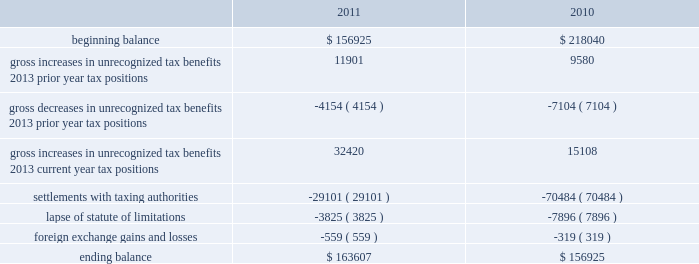A valuation allowance has been established for certain deferred tax assets related to the impairment of investments .
Accounting for uncertainty in income taxes during fiscal 2011 and 2010 , our aggregate changes in our total gross amount of unrecognized tax benefits are summarized as follows ( in thousands ) : beginning balance gross increases in unrecognized tax benefits 2013 prior year tax positions gross decreases in unrecognized tax benefits 2013 prior year tax positions gross increases in unrecognized tax benefits 2013 current year tax positions settlements with taxing authorities lapse of statute of limitations foreign exchange gains and losses ending balance $ 156925 11901 ( 4154 ) 32420 ( 29101 ) ( 3825 ) $ 163607 $ 218040 ( 7104 ) 15108 ( 70484 ) ( 7896 ) $ 156925 as of december 2 , 2011 , the combined amount of accrued interest and penalties related to tax positions taken on our tax returns and included in non-current income taxes payable was approximately $ 12.3 million .
We file income tax returns in the u.s .
On a federal basis and in many u.s .
State and foreign jurisdictions .
We are subject to the continual examination of our income tax returns by the irs and other domestic and foreign tax authorities .
Our major tax jurisdictions are the u.s. , ireland and california .
For california , ireland and the u.s. , the earliest fiscal years open for examination are 2005 , 2006 and 2008 , respectively .
We regularly assess the likelihood of outcomes resulting from these examinations to determine the adequacy of our provision for income taxes and have reserved for potential adjustments that may result from the current examination .
We believe such estimates to be reasonable ; however , there can be no assurance that the final determination of any of these examinations will not have an adverse effect on our operating results and financial position .
In august 2011 , a canadian income tax examination covering our fiscal years 2005 through 2008 was completed .
Our accrued tax and interest related to these years was approximately $ 35 million and was previously reported in long-term income taxes payable .
We reclassified approximately $ 17 million to short-term income taxes payable and decreased deferred tax assets by approximately $ 18 million in conjunction with the aforementioned resolution .
The $ 17 million balance in short-term income taxes payable is partially secured by a letter of credit and is expected to be paid by the first quarter of fiscal 2012 .
In october 2010 , a u.s .
Income tax examination covering our fiscal years 2005 through 2007 was completed .
Our accrued tax and interest related to these years was $ 59 million and was previously reported in long-term income taxes payable .
We paid $ 20 million in conjunction with the aforementioned resolution .
A net income statement tax benefit in the fourth quarter of fiscal 2010 of $ 39 million resulted .
The timing of the resolution of income tax examinations is highly uncertain as are the amounts and timing of tax payments that are part of any audit settlement process .
These events could cause large fluctuations in the balance sheet classification of current and non-current assets and liabilities .
The company believes that before the end of fiscal 2012 , it is reasonably possible that either certain audits will conclude or statutes of limitations on certain income tax examination periods will expire , or both .
Given the uncertainties described above , we can only determine a range of estimated potential decreases in underlying unrecognized tax benefits ranging from $ 0 to approximately $ 40 million .
These amounts would decrease income tax expense under current gaap related to income taxes .
Note 11 .
Restructuring fiscal 2011 restructuring plan in the fourth quarter of fiscal 2011 , in order to better align our resources around our digital media and digital marketing strategies , we initiated a restructuring plan consisting of reductions of approximately 700 full-time positions worldwide and we recorded restructuring charges of approximately $ 78.6 million related to ongoing termination benefits for the position eliminated .
Table of contents adobe systems incorporated notes to consolidated financial statements ( continued ) .
A valuation allowance has been established for certain deferred tax assets related to the impairment of investments .
Accounting for uncertainty in income taxes during fiscal 2011 and 2010 , our aggregate changes in our total gross amount of unrecognized tax benefits are summarized as follows ( in thousands ) : beginning balance gross increases in unrecognized tax benefits 2013 prior year tax positions gross decreases in unrecognized tax benefits 2013 prior year tax positions gross increases in unrecognized tax benefits 2013 current year tax positions settlements with taxing authorities lapse of statute of limitations foreign exchange gains and losses ending balance $ 156925 11901 ( 4154 ) 32420 ( 29101 ) ( 3825 ) $ 163607 $ 218040 ( 7104 ) 15108 ( 70484 ) ( 7896 ) $ 156925 as of december 2 , 2011 , the combined amount of accrued interest and penalties related to tax positions taken on our tax returns and included in non-current income taxes payable was approximately $ 12.3 million .
We file income tax returns in the u.s .
On a federal basis and in many u.s .
State and foreign jurisdictions .
We are subject to the continual examination of our income tax returns by the irs and other domestic and foreign tax authorities .
Our major tax jurisdictions are the u.s. , ireland and california .
For california , ireland and the u.s. , the earliest fiscal years open for examination are 2005 , 2006 and 2008 , respectively .
We regularly assess the likelihood of outcomes resulting from these examinations to determine the adequacy of our provision for income taxes and have reserved for potential adjustments that may result from the current examination .
We believe such estimates to be reasonable ; however , there can be no assurance that the final determination of any of these examinations will not have an adverse effect on our operating results and financial position .
In august 2011 , a canadian income tax examination covering our fiscal years 2005 through 2008 was completed .
Our accrued tax and interest related to these years was approximately $ 35 million and was previously reported in long-term income taxes payable .
We reclassified approximately $ 17 million to short-term income taxes payable and decreased deferred tax assets by approximately $ 18 million in conjunction with the aforementioned resolution .
The $ 17 million balance in short-term income taxes payable is partially secured by a letter of credit and is expected to be paid by the first quarter of fiscal 2012 .
In october 2010 , a u.s .
Income tax examination covering our fiscal years 2005 through 2007 was completed .
Our accrued tax and interest related to these years was $ 59 million and was previously reported in long-term income taxes payable .
We paid $ 20 million in conjunction with the aforementioned resolution .
A net income statement tax benefit in the fourth quarter of fiscal 2010 of $ 39 million resulted .
The timing of the resolution of income tax examinations is highly uncertain as are the amounts and timing of tax payments that are part of any audit settlement process .
These events could cause large fluctuations in the balance sheet classification of current and non-current assets and liabilities .
The company believes that before the end of fiscal 2012 , it is reasonably possible that either certain audits will conclude or statutes of limitations on certain income tax examination periods will expire , or both .
Given the uncertainties described above , we can only determine a range of estimated potential decreases in underlying unrecognized tax benefits ranging from $ 0 to approximately $ 40 million .
These amounts would decrease income tax expense under current gaap related to income taxes .
Note 11 .
Restructuring fiscal 2011 restructuring plan in the fourth quarter of fiscal 2011 , in order to better align our resources around our digital media and digital marketing strategies , we initiated a restructuring plan consisting of reductions of approximately 700 full-time positions worldwide and we recorded restructuring charges of approximately $ 78.6 million related to ongoing termination benefits for the position eliminated .
Table of contents adobe systems incorporated notes to consolidated financial statements ( continued ) .
What is the average range of estimated potential decreases in underlying unrecognized tax benefits in millions? 
Computations: ((0 + 40) / 2)
Answer: 20.0. 